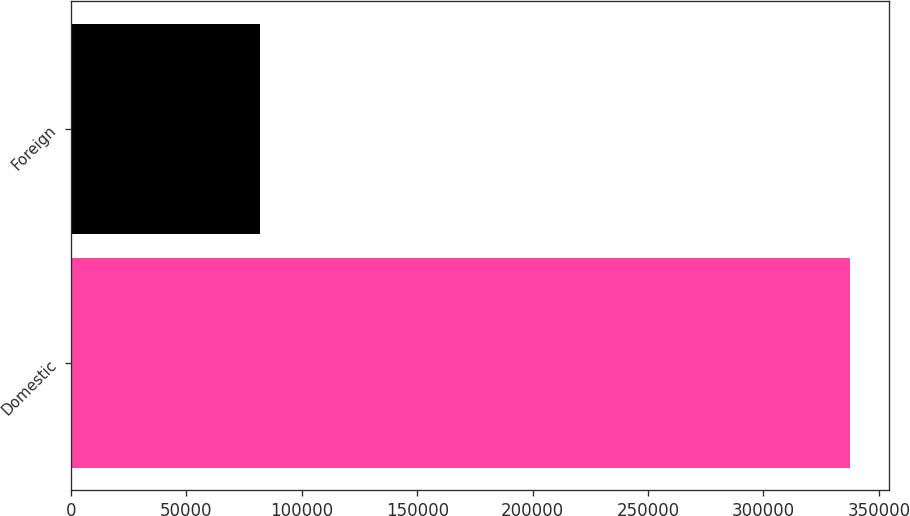Convert chart to OTSL. <chart><loc_0><loc_0><loc_500><loc_500><bar_chart><fcel>Domestic<fcel>Foreign<nl><fcel>337402<fcel>81874<nl></chart> 